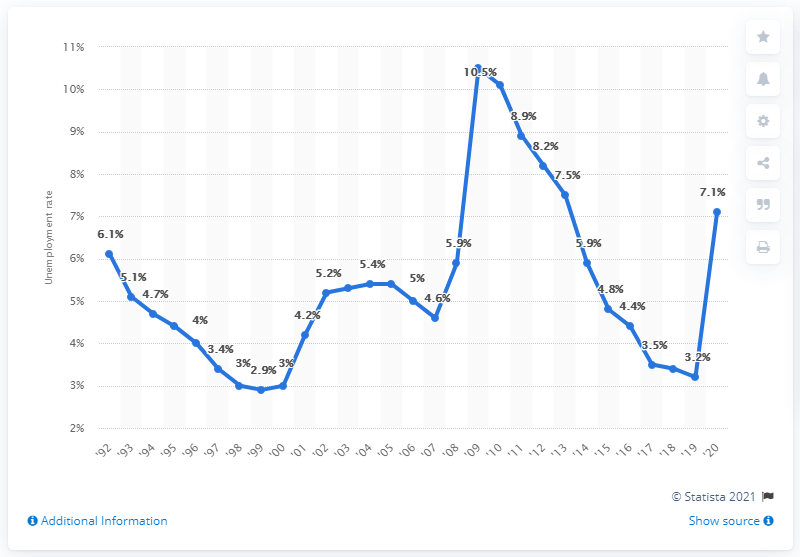Highlight a few significant elements in this photo. According to data from 2020, the unemployment rate in Indiana was 7.1%. 